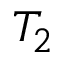Convert formula to latex. <formula><loc_0><loc_0><loc_500><loc_500>T _ { 2 }</formula> 